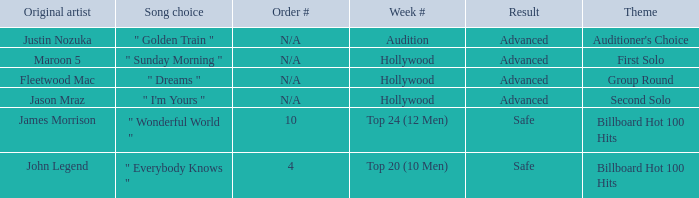What are all of the order # where authentic artist is maroon 5 N/A. 